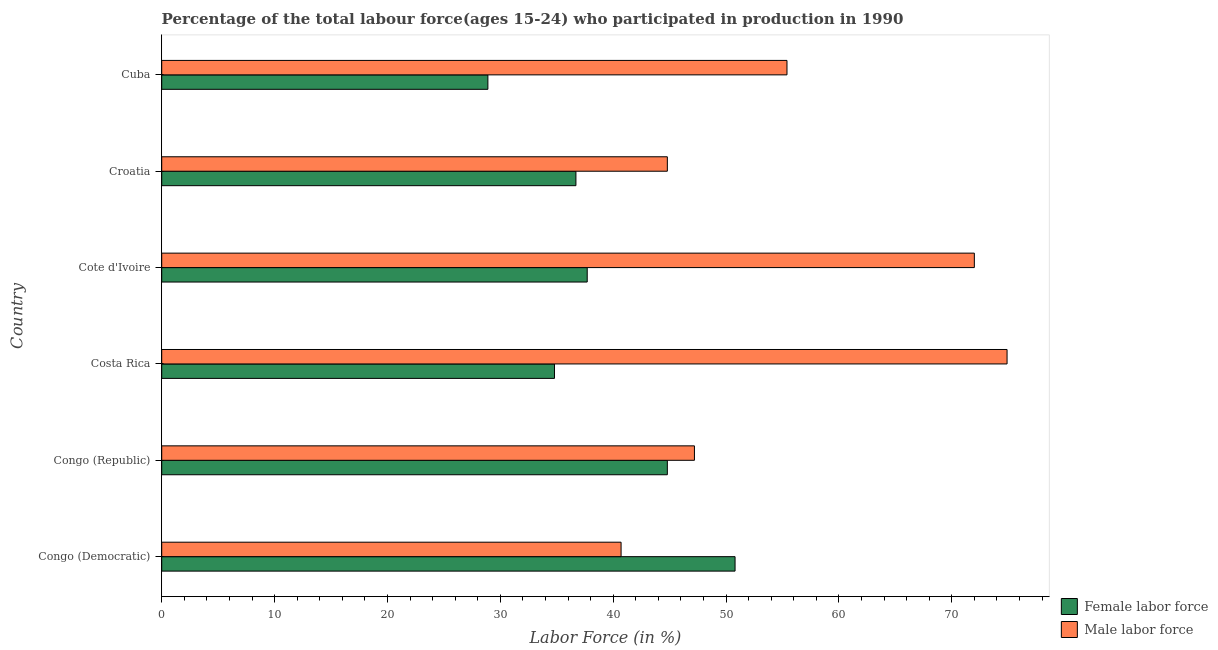How many groups of bars are there?
Your response must be concise. 6. Are the number of bars per tick equal to the number of legend labels?
Your response must be concise. Yes. Are the number of bars on each tick of the Y-axis equal?
Give a very brief answer. Yes. What is the label of the 2nd group of bars from the top?
Your answer should be very brief. Croatia. What is the percentage of male labour force in Cote d'Ivoire?
Offer a terse response. 72. Across all countries, what is the maximum percentage of female labor force?
Provide a short and direct response. 50.8. Across all countries, what is the minimum percentage of female labor force?
Ensure brevity in your answer.  28.9. In which country was the percentage of male labour force maximum?
Your response must be concise. Costa Rica. In which country was the percentage of female labor force minimum?
Provide a succinct answer. Cuba. What is the total percentage of male labour force in the graph?
Make the answer very short. 335. What is the difference between the percentage of female labor force in Congo (Republic) and that in Cuba?
Provide a succinct answer. 15.9. What is the difference between the percentage of female labor force in Croatia and the percentage of male labour force in Congo (Republic)?
Make the answer very short. -10.5. What is the average percentage of female labor force per country?
Your answer should be very brief. 38.95. What is the difference between the percentage of female labor force and percentage of male labour force in Cuba?
Make the answer very short. -26.5. What is the ratio of the percentage of male labour force in Congo (Republic) to that in Cote d'Ivoire?
Keep it short and to the point. 0.66. Is the difference between the percentage of female labor force in Costa Rica and Croatia greater than the difference between the percentage of male labour force in Costa Rica and Croatia?
Provide a short and direct response. No. What is the difference between the highest and the second highest percentage of male labour force?
Give a very brief answer. 2.9. What is the difference between the highest and the lowest percentage of male labour force?
Ensure brevity in your answer.  34.2. What does the 1st bar from the top in Cuba represents?
Your response must be concise. Male labor force. What does the 2nd bar from the bottom in Croatia represents?
Keep it short and to the point. Male labor force. How many bars are there?
Make the answer very short. 12. Are all the bars in the graph horizontal?
Provide a short and direct response. Yes. How many countries are there in the graph?
Your answer should be compact. 6. What is the difference between two consecutive major ticks on the X-axis?
Offer a terse response. 10. Are the values on the major ticks of X-axis written in scientific E-notation?
Provide a short and direct response. No. Does the graph contain grids?
Give a very brief answer. No. How are the legend labels stacked?
Make the answer very short. Vertical. What is the title of the graph?
Provide a succinct answer. Percentage of the total labour force(ages 15-24) who participated in production in 1990. What is the Labor Force (in %) in Female labor force in Congo (Democratic)?
Ensure brevity in your answer.  50.8. What is the Labor Force (in %) of Male labor force in Congo (Democratic)?
Provide a short and direct response. 40.7. What is the Labor Force (in %) in Female labor force in Congo (Republic)?
Offer a very short reply. 44.8. What is the Labor Force (in %) in Male labor force in Congo (Republic)?
Give a very brief answer. 47.2. What is the Labor Force (in %) of Female labor force in Costa Rica?
Provide a short and direct response. 34.8. What is the Labor Force (in %) in Male labor force in Costa Rica?
Your answer should be very brief. 74.9. What is the Labor Force (in %) in Female labor force in Cote d'Ivoire?
Your response must be concise. 37.7. What is the Labor Force (in %) of Male labor force in Cote d'Ivoire?
Provide a short and direct response. 72. What is the Labor Force (in %) in Female labor force in Croatia?
Give a very brief answer. 36.7. What is the Labor Force (in %) in Male labor force in Croatia?
Offer a very short reply. 44.8. What is the Labor Force (in %) in Female labor force in Cuba?
Your answer should be compact. 28.9. What is the Labor Force (in %) of Male labor force in Cuba?
Offer a terse response. 55.4. Across all countries, what is the maximum Labor Force (in %) in Female labor force?
Your answer should be compact. 50.8. Across all countries, what is the maximum Labor Force (in %) in Male labor force?
Your answer should be compact. 74.9. Across all countries, what is the minimum Labor Force (in %) in Female labor force?
Give a very brief answer. 28.9. Across all countries, what is the minimum Labor Force (in %) of Male labor force?
Provide a short and direct response. 40.7. What is the total Labor Force (in %) of Female labor force in the graph?
Give a very brief answer. 233.7. What is the total Labor Force (in %) of Male labor force in the graph?
Make the answer very short. 335. What is the difference between the Labor Force (in %) of Female labor force in Congo (Democratic) and that in Congo (Republic)?
Your answer should be very brief. 6. What is the difference between the Labor Force (in %) in Male labor force in Congo (Democratic) and that in Congo (Republic)?
Your answer should be compact. -6.5. What is the difference between the Labor Force (in %) in Male labor force in Congo (Democratic) and that in Costa Rica?
Offer a terse response. -34.2. What is the difference between the Labor Force (in %) of Female labor force in Congo (Democratic) and that in Cote d'Ivoire?
Give a very brief answer. 13.1. What is the difference between the Labor Force (in %) in Male labor force in Congo (Democratic) and that in Cote d'Ivoire?
Your response must be concise. -31.3. What is the difference between the Labor Force (in %) of Female labor force in Congo (Democratic) and that in Croatia?
Your answer should be very brief. 14.1. What is the difference between the Labor Force (in %) of Male labor force in Congo (Democratic) and that in Croatia?
Make the answer very short. -4.1. What is the difference between the Labor Force (in %) in Female labor force in Congo (Democratic) and that in Cuba?
Your answer should be compact. 21.9. What is the difference between the Labor Force (in %) in Male labor force in Congo (Democratic) and that in Cuba?
Your response must be concise. -14.7. What is the difference between the Labor Force (in %) in Female labor force in Congo (Republic) and that in Costa Rica?
Offer a terse response. 10. What is the difference between the Labor Force (in %) of Male labor force in Congo (Republic) and that in Costa Rica?
Ensure brevity in your answer.  -27.7. What is the difference between the Labor Force (in %) of Female labor force in Congo (Republic) and that in Cote d'Ivoire?
Provide a short and direct response. 7.1. What is the difference between the Labor Force (in %) in Male labor force in Congo (Republic) and that in Cote d'Ivoire?
Ensure brevity in your answer.  -24.8. What is the difference between the Labor Force (in %) of Male labor force in Congo (Republic) and that in Croatia?
Make the answer very short. 2.4. What is the difference between the Labor Force (in %) in Female labor force in Congo (Republic) and that in Cuba?
Your answer should be compact. 15.9. What is the difference between the Labor Force (in %) in Male labor force in Congo (Republic) and that in Cuba?
Make the answer very short. -8.2. What is the difference between the Labor Force (in %) in Female labor force in Costa Rica and that in Cote d'Ivoire?
Ensure brevity in your answer.  -2.9. What is the difference between the Labor Force (in %) in Female labor force in Costa Rica and that in Croatia?
Provide a short and direct response. -1.9. What is the difference between the Labor Force (in %) in Male labor force in Costa Rica and that in Croatia?
Provide a succinct answer. 30.1. What is the difference between the Labor Force (in %) of Male labor force in Costa Rica and that in Cuba?
Make the answer very short. 19.5. What is the difference between the Labor Force (in %) in Male labor force in Cote d'Ivoire and that in Croatia?
Your answer should be very brief. 27.2. What is the difference between the Labor Force (in %) in Female labor force in Cote d'Ivoire and that in Cuba?
Make the answer very short. 8.8. What is the difference between the Labor Force (in %) in Male labor force in Cote d'Ivoire and that in Cuba?
Give a very brief answer. 16.6. What is the difference between the Labor Force (in %) of Male labor force in Croatia and that in Cuba?
Your response must be concise. -10.6. What is the difference between the Labor Force (in %) of Female labor force in Congo (Democratic) and the Labor Force (in %) of Male labor force in Costa Rica?
Your response must be concise. -24.1. What is the difference between the Labor Force (in %) in Female labor force in Congo (Democratic) and the Labor Force (in %) in Male labor force in Cote d'Ivoire?
Offer a very short reply. -21.2. What is the difference between the Labor Force (in %) of Female labor force in Congo (Democratic) and the Labor Force (in %) of Male labor force in Croatia?
Give a very brief answer. 6. What is the difference between the Labor Force (in %) of Female labor force in Congo (Republic) and the Labor Force (in %) of Male labor force in Costa Rica?
Offer a very short reply. -30.1. What is the difference between the Labor Force (in %) of Female labor force in Congo (Republic) and the Labor Force (in %) of Male labor force in Cote d'Ivoire?
Keep it short and to the point. -27.2. What is the difference between the Labor Force (in %) of Female labor force in Congo (Republic) and the Labor Force (in %) of Male labor force in Cuba?
Ensure brevity in your answer.  -10.6. What is the difference between the Labor Force (in %) in Female labor force in Costa Rica and the Labor Force (in %) in Male labor force in Cote d'Ivoire?
Provide a short and direct response. -37.2. What is the difference between the Labor Force (in %) in Female labor force in Costa Rica and the Labor Force (in %) in Male labor force in Croatia?
Give a very brief answer. -10. What is the difference between the Labor Force (in %) of Female labor force in Costa Rica and the Labor Force (in %) of Male labor force in Cuba?
Ensure brevity in your answer.  -20.6. What is the difference between the Labor Force (in %) in Female labor force in Cote d'Ivoire and the Labor Force (in %) in Male labor force in Croatia?
Give a very brief answer. -7.1. What is the difference between the Labor Force (in %) of Female labor force in Cote d'Ivoire and the Labor Force (in %) of Male labor force in Cuba?
Ensure brevity in your answer.  -17.7. What is the difference between the Labor Force (in %) in Female labor force in Croatia and the Labor Force (in %) in Male labor force in Cuba?
Make the answer very short. -18.7. What is the average Labor Force (in %) of Female labor force per country?
Your answer should be very brief. 38.95. What is the average Labor Force (in %) in Male labor force per country?
Keep it short and to the point. 55.83. What is the difference between the Labor Force (in %) of Female labor force and Labor Force (in %) of Male labor force in Congo (Democratic)?
Your answer should be very brief. 10.1. What is the difference between the Labor Force (in %) in Female labor force and Labor Force (in %) in Male labor force in Congo (Republic)?
Provide a short and direct response. -2.4. What is the difference between the Labor Force (in %) in Female labor force and Labor Force (in %) in Male labor force in Costa Rica?
Offer a terse response. -40.1. What is the difference between the Labor Force (in %) in Female labor force and Labor Force (in %) in Male labor force in Cote d'Ivoire?
Provide a succinct answer. -34.3. What is the difference between the Labor Force (in %) in Female labor force and Labor Force (in %) in Male labor force in Croatia?
Provide a succinct answer. -8.1. What is the difference between the Labor Force (in %) in Female labor force and Labor Force (in %) in Male labor force in Cuba?
Ensure brevity in your answer.  -26.5. What is the ratio of the Labor Force (in %) of Female labor force in Congo (Democratic) to that in Congo (Republic)?
Keep it short and to the point. 1.13. What is the ratio of the Labor Force (in %) of Male labor force in Congo (Democratic) to that in Congo (Republic)?
Offer a very short reply. 0.86. What is the ratio of the Labor Force (in %) in Female labor force in Congo (Democratic) to that in Costa Rica?
Make the answer very short. 1.46. What is the ratio of the Labor Force (in %) in Male labor force in Congo (Democratic) to that in Costa Rica?
Provide a short and direct response. 0.54. What is the ratio of the Labor Force (in %) in Female labor force in Congo (Democratic) to that in Cote d'Ivoire?
Your answer should be compact. 1.35. What is the ratio of the Labor Force (in %) of Male labor force in Congo (Democratic) to that in Cote d'Ivoire?
Provide a short and direct response. 0.57. What is the ratio of the Labor Force (in %) in Female labor force in Congo (Democratic) to that in Croatia?
Your answer should be very brief. 1.38. What is the ratio of the Labor Force (in %) of Male labor force in Congo (Democratic) to that in Croatia?
Offer a terse response. 0.91. What is the ratio of the Labor Force (in %) in Female labor force in Congo (Democratic) to that in Cuba?
Give a very brief answer. 1.76. What is the ratio of the Labor Force (in %) in Male labor force in Congo (Democratic) to that in Cuba?
Keep it short and to the point. 0.73. What is the ratio of the Labor Force (in %) of Female labor force in Congo (Republic) to that in Costa Rica?
Provide a succinct answer. 1.29. What is the ratio of the Labor Force (in %) in Male labor force in Congo (Republic) to that in Costa Rica?
Offer a very short reply. 0.63. What is the ratio of the Labor Force (in %) in Female labor force in Congo (Republic) to that in Cote d'Ivoire?
Make the answer very short. 1.19. What is the ratio of the Labor Force (in %) of Male labor force in Congo (Republic) to that in Cote d'Ivoire?
Offer a terse response. 0.66. What is the ratio of the Labor Force (in %) in Female labor force in Congo (Republic) to that in Croatia?
Ensure brevity in your answer.  1.22. What is the ratio of the Labor Force (in %) in Male labor force in Congo (Republic) to that in Croatia?
Ensure brevity in your answer.  1.05. What is the ratio of the Labor Force (in %) in Female labor force in Congo (Republic) to that in Cuba?
Your answer should be very brief. 1.55. What is the ratio of the Labor Force (in %) in Male labor force in Congo (Republic) to that in Cuba?
Your response must be concise. 0.85. What is the ratio of the Labor Force (in %) in Female labor force in Costa Rica to that in Cote d'Ivoire?
Offer a very short reply. 0.92. What is the ratio of the Labor Force (in %) in Male labor force in Costa Rica to that in Cote d'Ivoire?
Offer a very short reply. 1.04. What is the ratio of the Labor Force (in %) in Female labor force in Costa Rica to that in Croatia?
Provide a succinct answer. 0.95. What is the ratio of the Labor Force (in %) in Male labor force in Costa Rica to that in Croatia?
Your response must be concise. 1.67. What is the ratio of the Labor Force (in %) in Female labor force in Costa Rica to that in Cuba?
Offer a very short reply. 1.2. What is the ratio of the Labor Force (in %) of Male labor force in Costa Rica to that in Cuba?
Provide a short and direct response. 1.35. What is the ratio of the Labor Force (in %) of Female labor force in Cote d'Ivoire to that in Croatia?
Make the answer very short. 1.03. What is the ratio of the Labor Force (in %) in Male labor force in Cote d'Ivoire to that in Croatia?
Your answer should be very brief. 1.61. What is the ratio of the Labor Force (in %) in Female labor force in Cote d'Ivoire to that in Cuba?
Keep it short and to the point. 1.3. What is the ratio of the Labor Force (in %) of Male labor force in Cote d'Ivoire to that in Cuba?
Your answer should be very brief. 1.3. What is the ratio of the Labor Force (in %) of Female labor force in Croatia to that in Cuba?
Offer a terse response. 1.27. What is the ratio of the Labor Force (in %) in Male labor force in Croatia to that in Cuba?
Ensure brevity in your answer.  0.81. What is the difference between the highest and the lowest Labor Force (in %) in Female labor force?
Offer a terse response. 21.9. What is the difference between the highest and the lowest Labor Force (in %) of Male labor force?
Provide a short and direct response. 34.2. 